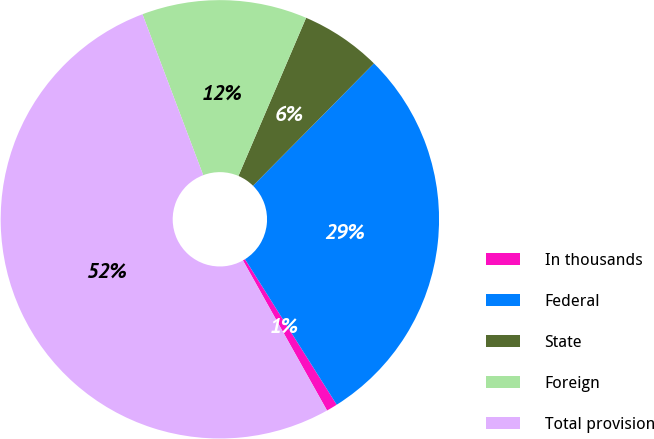Convert chart. <chart><loc_0><loc_0><loc_500><loc_500><pie_chart><fcel>In thousands<fcel>Federal<fcel>State<fcel>Foreign<fcel>Total provision<nl><fcel>0.82%<fcel>28.64%<fcel>5.97%<fcel>12.18%<fcel>52.38%<nl></chart> 